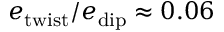Convert formula to latex. <formula><loc_0><loc_0><loc_500><loc_500>e _ { t w i s t } / e _ { d i p } \approx 0 . 0 6</formula> 